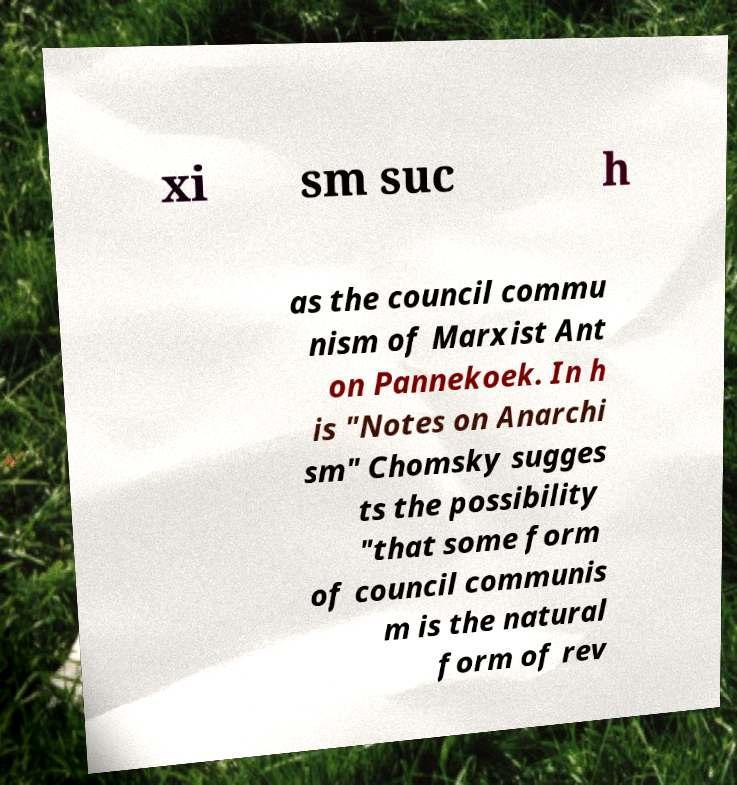Could you extract and type out the text from this image? xi sm suc h as the council commu nism of Marxist Ant on Pannekoek. In h is "Notes on Anarchi sm" Chomsky sugges ts the possibility "that some form of council communis m is the natural form of rev 